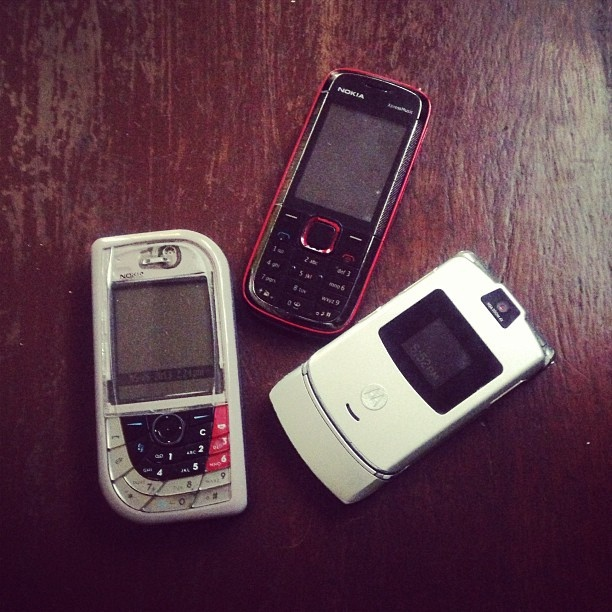Describe the objects in this image and their specific colors. I can see dining table in black, maroon, brown, darkgray, and purple tones, cell phone in black, gray, darkgray, and lightgray tones, cell phone in black, beige, and darkgray tones, and cell phone in black and purple tones in this image. 